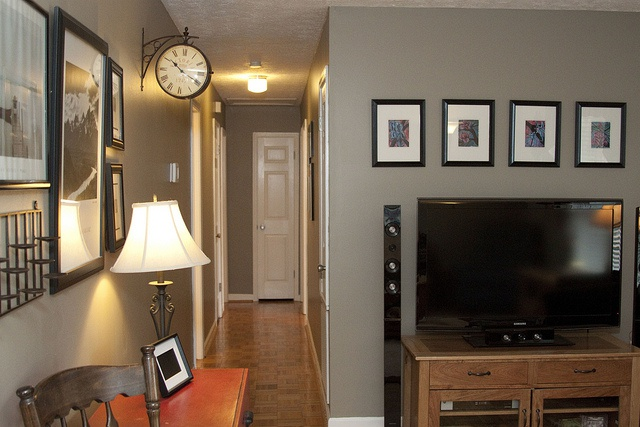Describe the objects in this image and their specific colors. I can see tv in darkgray, black, and gray tones, chair in darkgray, black, gray, and maroon tones, and clock in darkgray, tan, and black tones in this image. 